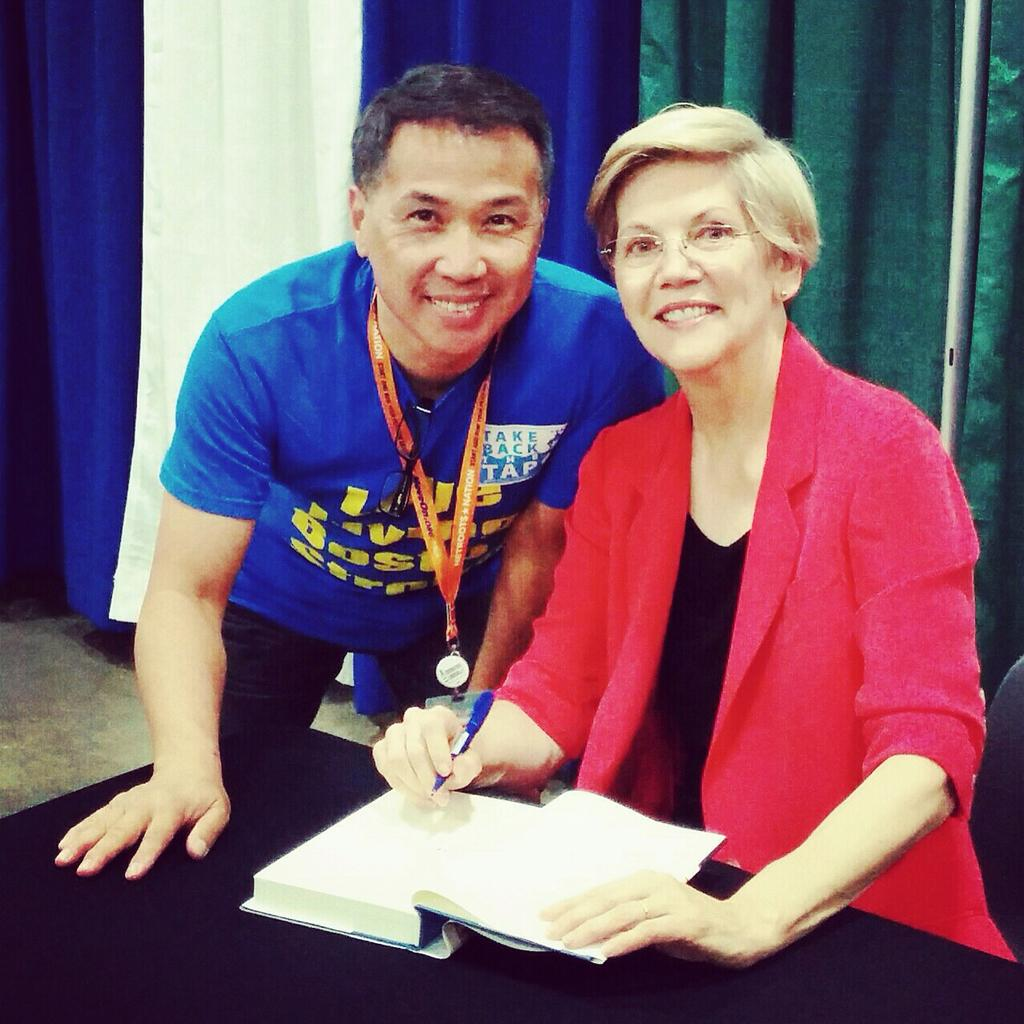What is the man doing in the image? The man is standing in the image. What is the woman doing in the image? The woman is sitting in the image and holding a book and a pen. Where are the book and pen placed in the image? The book and pen are placed on a table. What color is the quince in the image? There is no quince present in the image. How many eyes does the turkey have in the image? There is no turkey present in the image. 